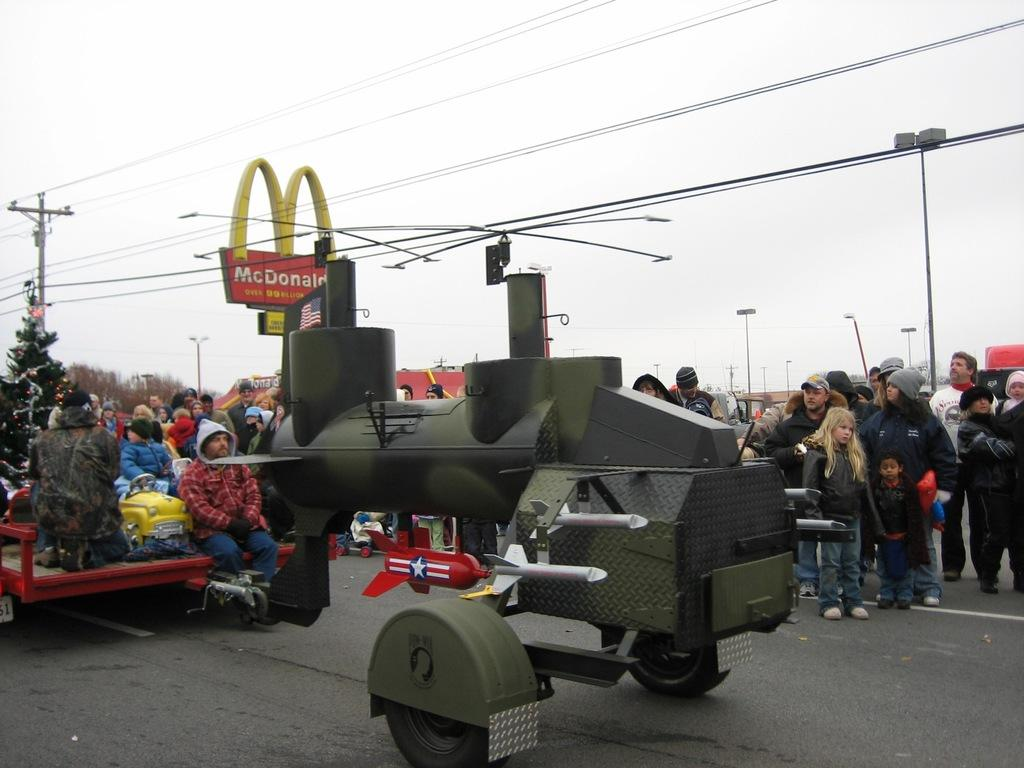What is the main subject of the image? There is a vehicle in the image. What else can be seen in the image besides the vehicle? There is a group of people standing on the road, trees, poles, wires, and the sky is visible in the background. Where is the lunchroom located in the image? There is no lunchroom present in the image. What type of cattle can be seen grazing in the image? There are no cattle present in the image. 